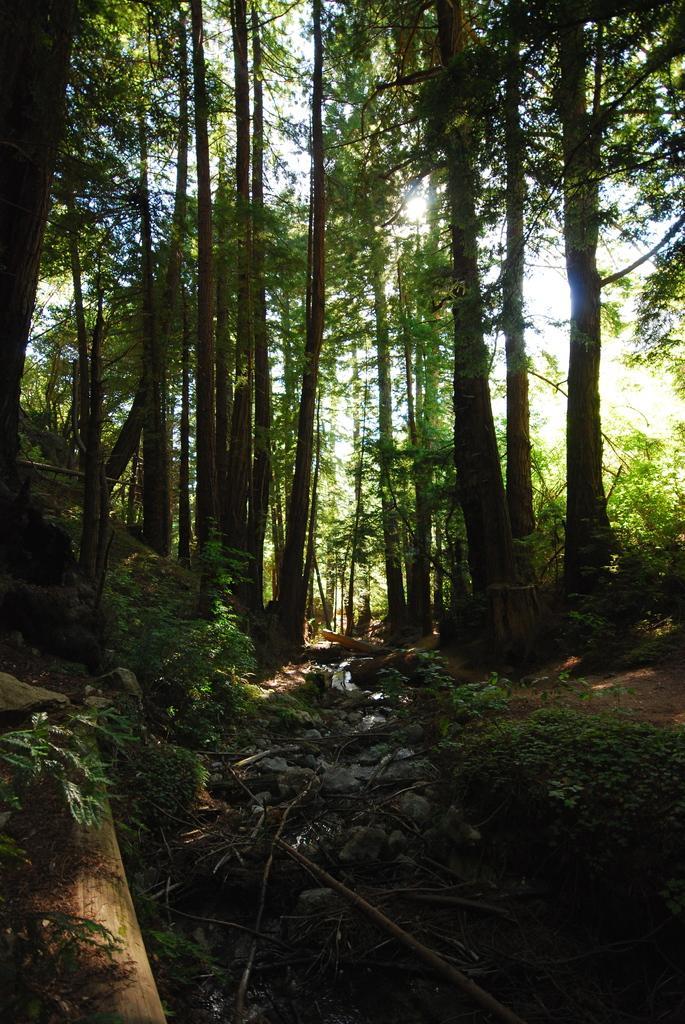Could you give a brief overview of what you see in this image? In this picture there are trees. At the top there is sky. At the bottom there are plants and stones and sticks. 